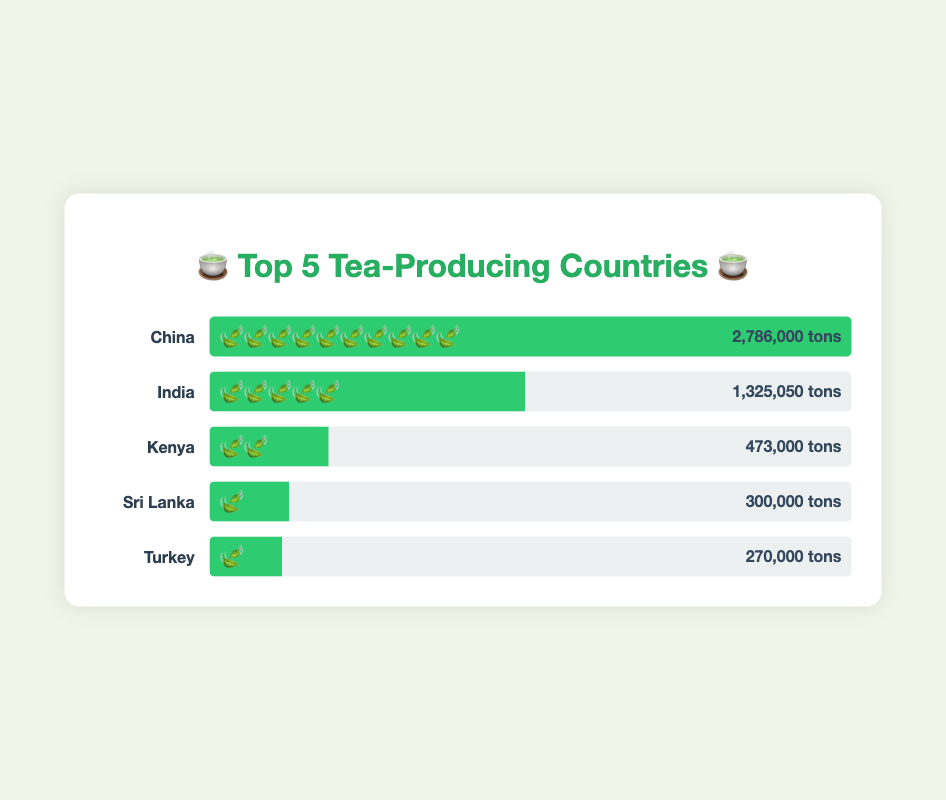Which country has the highest tea production? By examining the bars and output numbers, the tallest bar and largest number belongs to China with 2,786,000 tons.
Answer: China How much tea does India produce annually? The bar representing India is labeled with its production output, which is 1,325,050 tons.
Answer: 1,325,050 tons Which country produces the least amount of tea among the top 5? By comparing the lengths of the bars, Turkey (at the bottom) has the shortest bar, indicating the lowest production at 270,000 tons.
Answer: Turkey How many tea leaf emojis represent Kenya's tea production? The bar for Kenya has 2 tea leaf emojis, visually representing its production.
Answer: 2 What's the sum of the tea production for Sri Lanka and Turkey? Sri Lanka produces 300,000 tons and Turkey produces 270,000 tons. Adding them together gives 300,000 + 270,000 = 570,000 tons.
Answer: 570,000 tons How does India’s tea production compare to Kenya's? India has a bar with 5 tea leaf emojis and 1,325,050 tons of production, while Kenya has 2 tea leaf emojis and 473,000 tons, making India's production substantially larger.
Answer: India produces more Which two countries have the same number of tea leaf emojis despite different production outputs? Viewing the emojis, both Sri Lanka and Turkey each have 1 tea leaf emoji.
Answer: Sri Lanka and Turkey If you sum the tea production of the top 3 producing countries, what do you get? China produces 2,786,000 tons, India produces 1,325,050 tons, and Kenya produces 473,000 tons. Summing them, 2,786,000 + 1,325,050 + 473,000 = 4,584,050 tons.
Answer: 4,584,050 tons What percentage of China’s tea production is Kenya’s output? Kenya's production is 473,000 tons. China's is 2,786,000 tons. (473,000 / 2,786,000) * 100 ≈ 16.98%.
Answer: ~17% What is the ratio of India’s tea production to Sri Lanka’s? India produces 1,325,050 tons, Sri Lanka produces 300,000 tons. The ratio is 1,325,050 : 300,000, which reduces to approximately 4.42 : 1.
Answer: ~4.42:1 